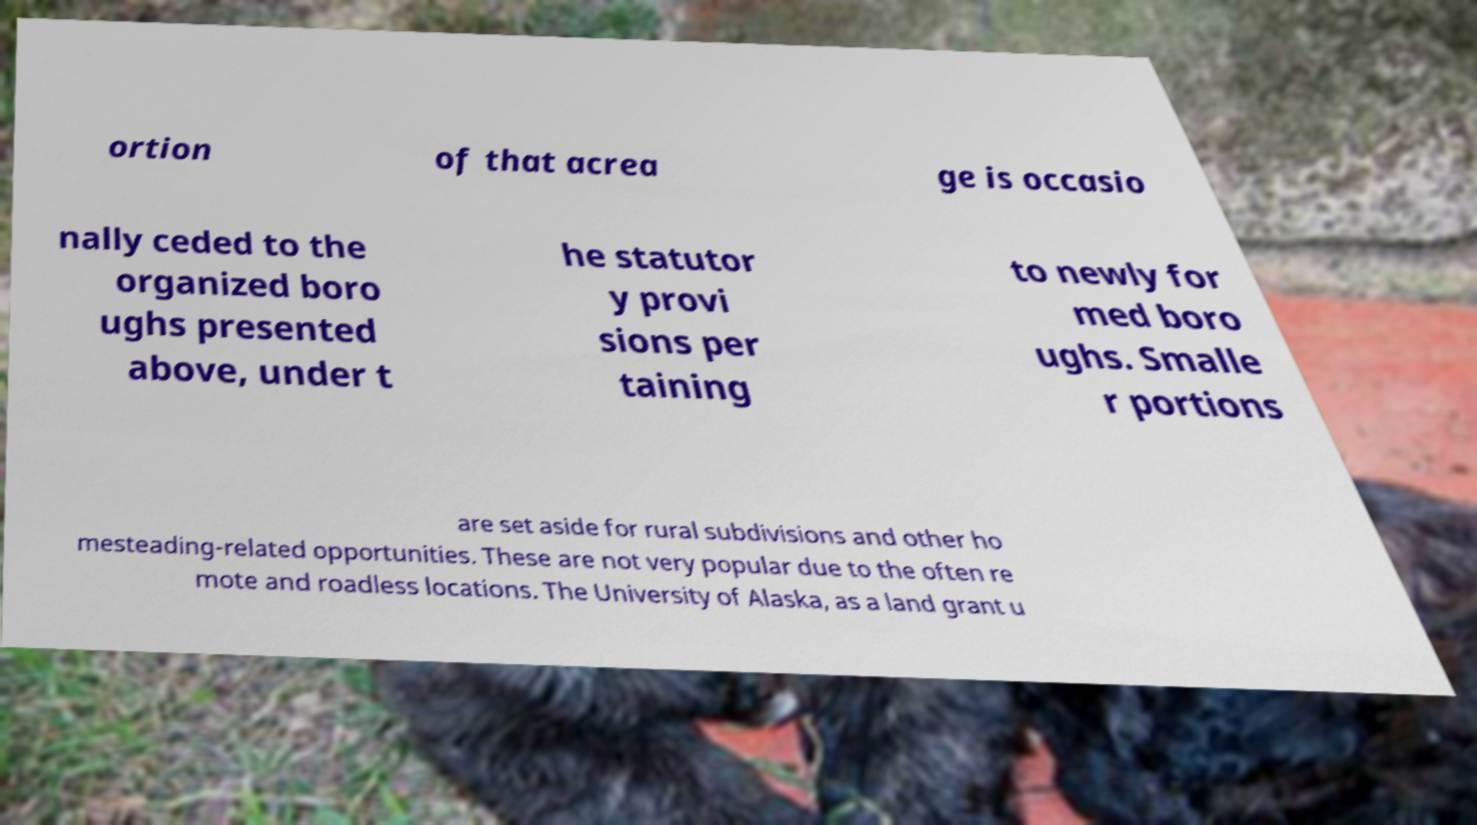There's text embedded in this image that I need extracted. Can you transcribe it verbatim? ortion of that acrea ge is occasio nally ceded to the organized boro ughs presented above, under t he statutor y provi sions per taining to newly for med boro ughs. Smalle r portions are set aside for rural subdivisions and other ho mesteading-related opportunities. These are not very popular due to the often re mote and roadless locations. The University of Alaska, as a land grant u 